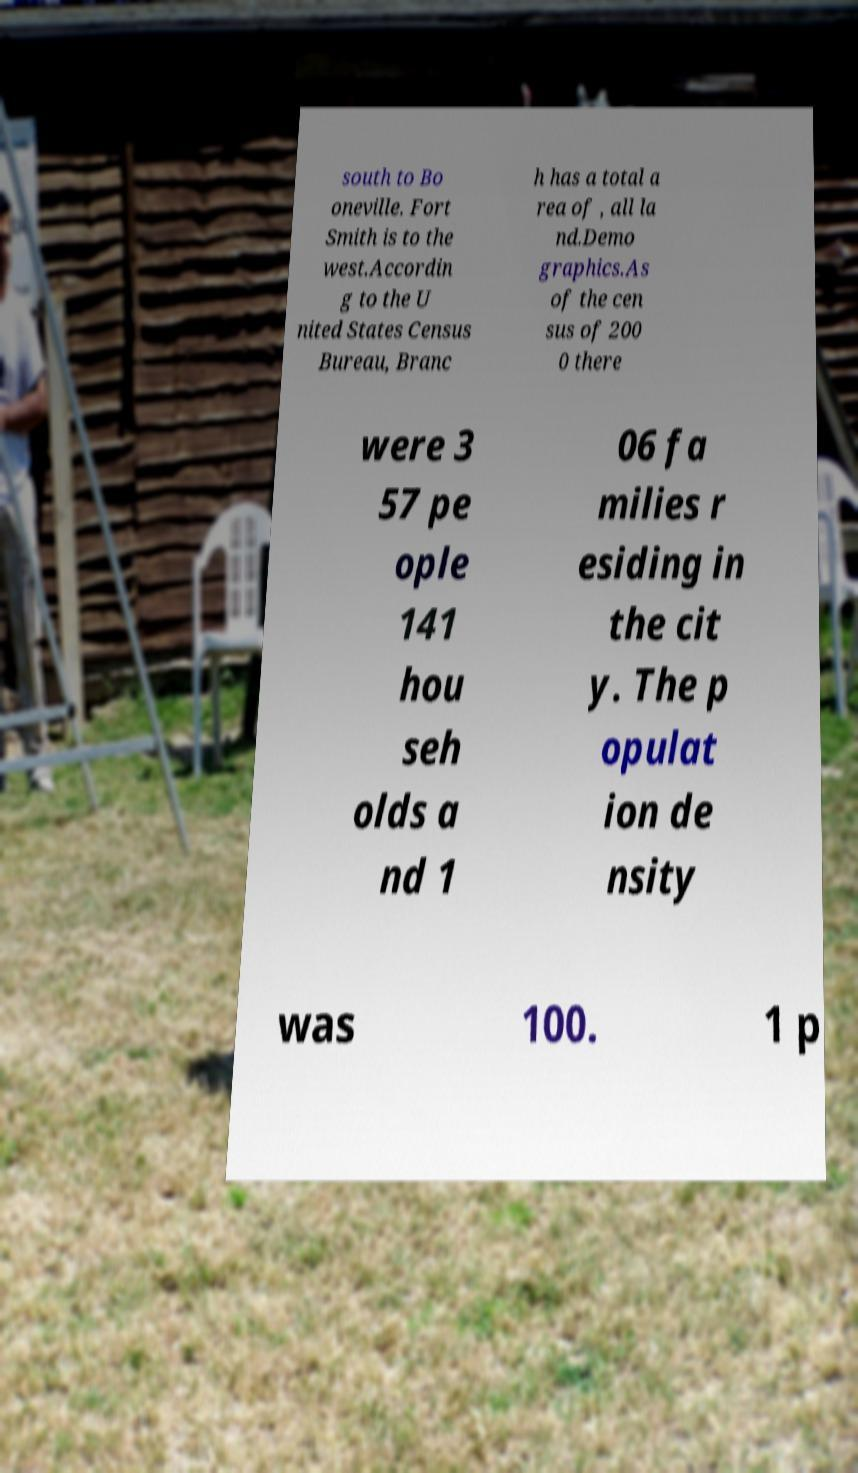Please identify and transcribe the text found in this image. south to Bo oneville. Fort Smith is to the west.Accordin g to the U nited States Census Bureau, Branc h has a total a rea of , all la nd.Demo graphics.As of the cen sus of 200 0 there were 3 57 pe ople 141 hou seh olds a nd 1 06 fa milies r esiding in the cit y. The p opulat ion de nsity was 100. 1 p 